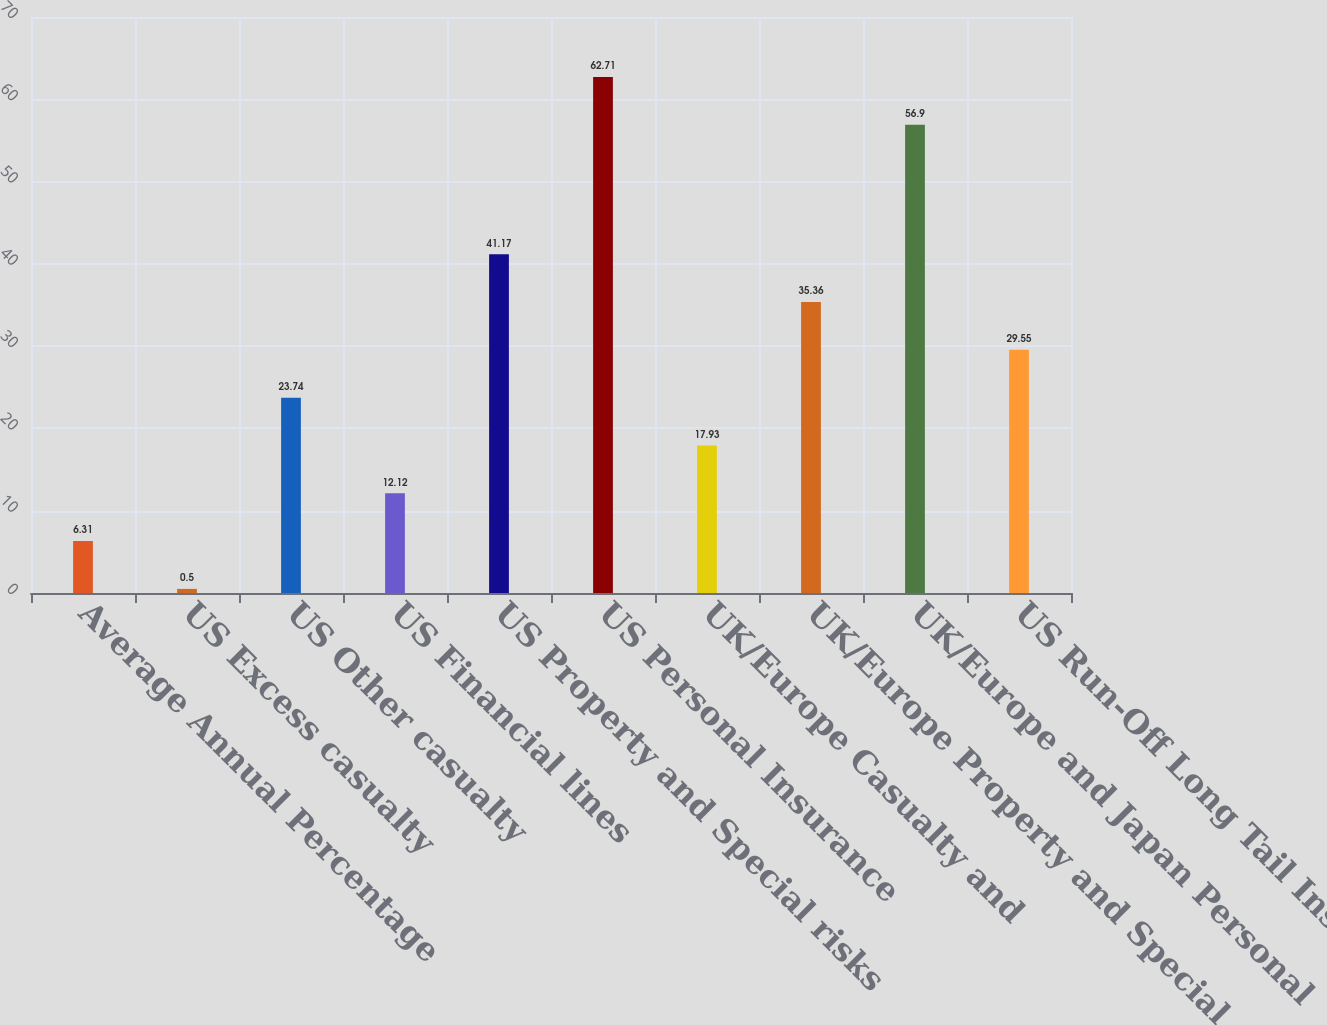Convert chart. <chart><loc_0><loc_0><loc_500><loc_500><bar_chart><fcel>Average Annual Percentage<fcel>US Excess casualty<fcel>US Other casualty<fcel>US Financial lines<fcel>US Property and Special risks<fcel>US Personal Insurance<fcel>UK/Europe Casualty and<fcel>UK/Europe Property and Special<fcel>UK/Europe and Japan Personal<fcel>US Run-Off Long Tail Insurance<nl><fcel>6.31<fcel>0.5<fcel>23.74<fcel>12.12<fcel>41.17<fcel>62.71<fcel>17.93<fcel>35.36<fcel>56.9<fcel>29.55<nl></chart> 